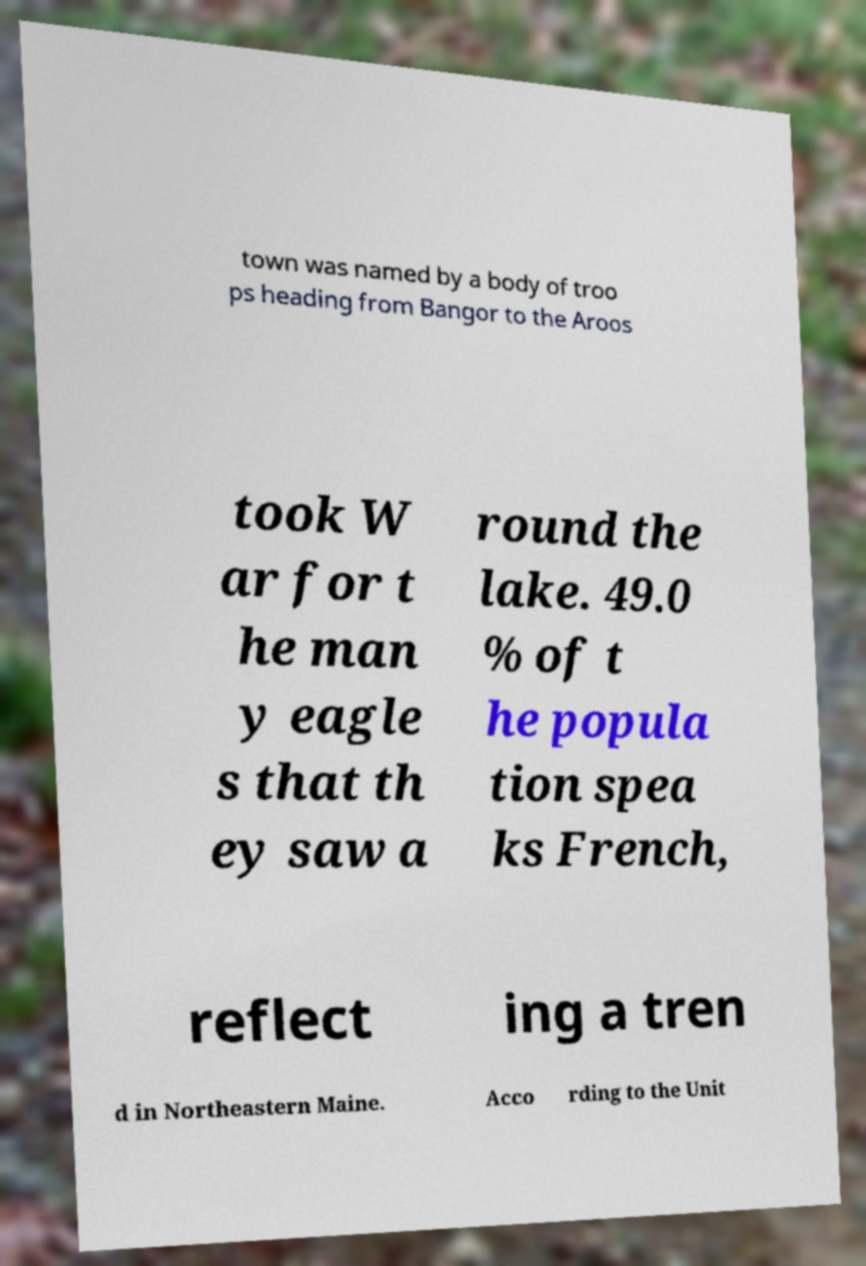For documentation purposes, I need the text within this image transcribed. Could you provide that? town was named by a body of troo ps heading from Bangor to the Aroos took W ar for t he man y eagle s that th ey saw a round the lake. 49.0 % of t he popula tion spea ks French, reflect ing a tren d in Northeastern Maine. Acco rding to the Unit 